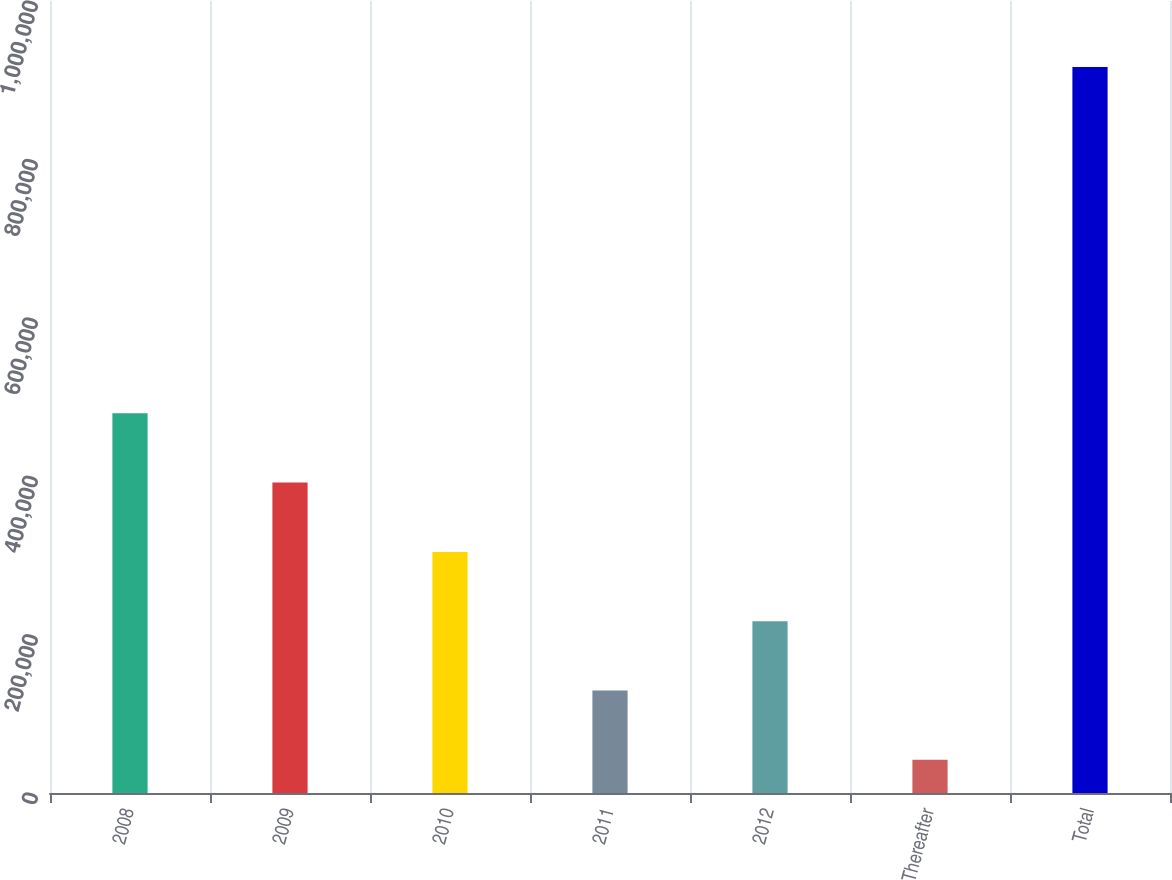Convert chart. <chart><loc_0><loc_0><loc_500><loc_500><bar_chart><fcel>2008<fcel>2009<fcel>2010<fcel>2011<fcel>2012<fcel>Thereafter<fcel>Total<nl><fcel>479364<fcel>391901<fcel>304438<fcel>129511<fcel>216975<fcel>42048<fcel>916681<nl></chart> 